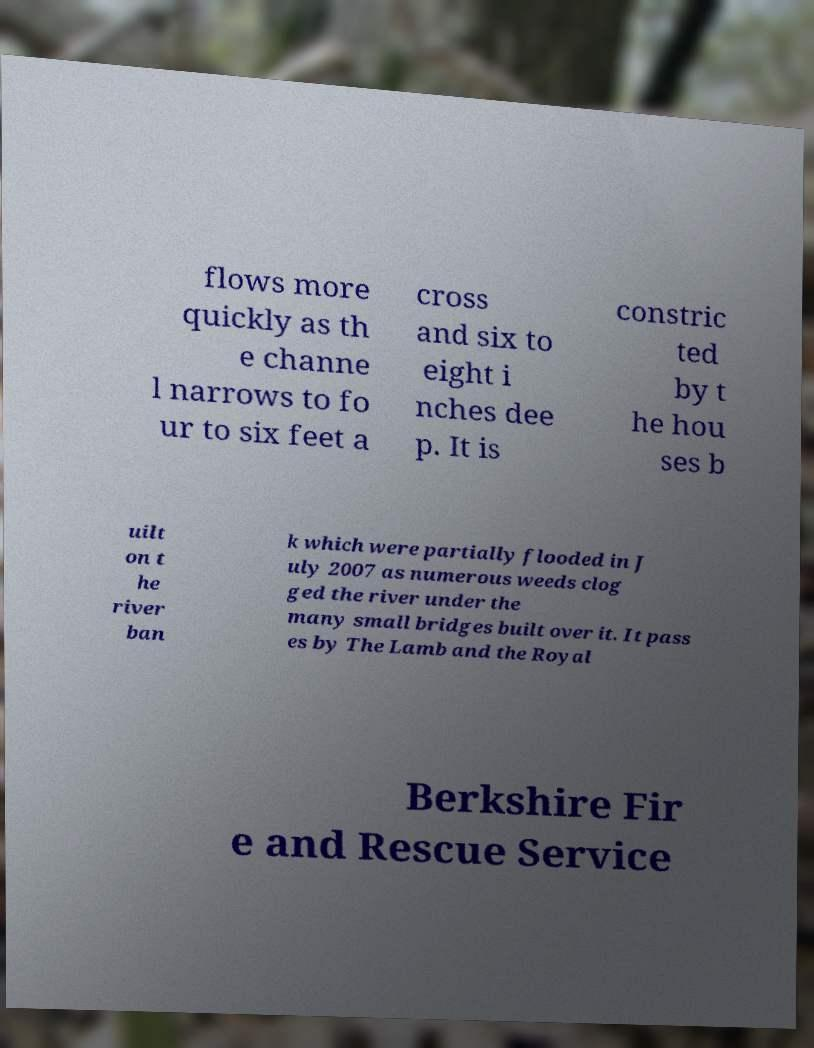For documentation purposes, I need the text within this image transcribed. Could you provide that? flows more quickly as th e channe l narrows to fo ur to six feet a cross and six to eight i nches dee p. It is constric ted by t he hou ses b uilt on t he river ban k which were partially flooded in J uly 2007 as numerous weeds clog ged the river under the many small bridges built over it. It pass es by The Lamb and the Royal Berkshire Fir e and Rescue Service 